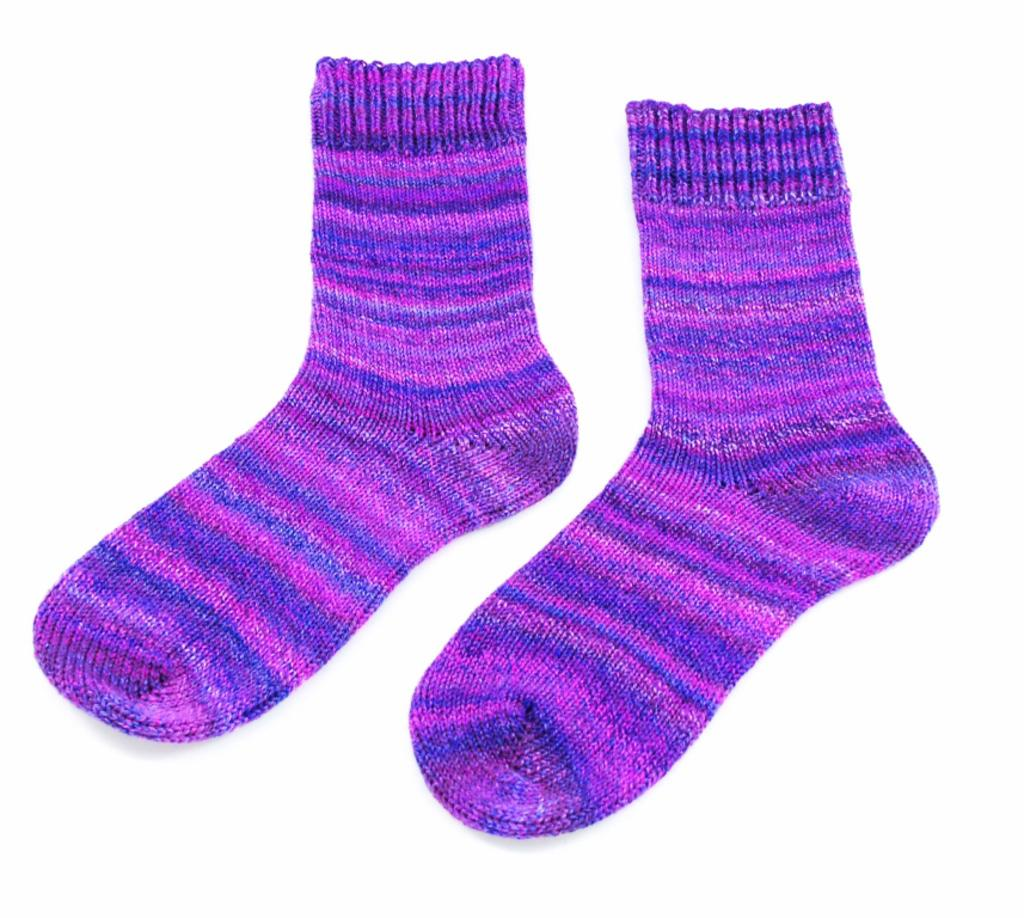What type of clothing item is in the image? There is a pair of socks in the image. What colors are the socks? The socks are purple and pink in color. What color is the background of the image? The background of the image is white. Can you see any dinosaurs in the image? No, there are no dinosaurs present in the image. What type of tub is visible in the image? There is no tub present in the image. 